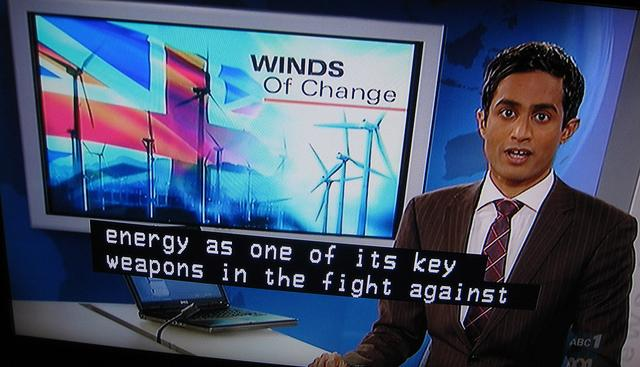Which national flag is in the segment screen of this broadcast? united kingdom 